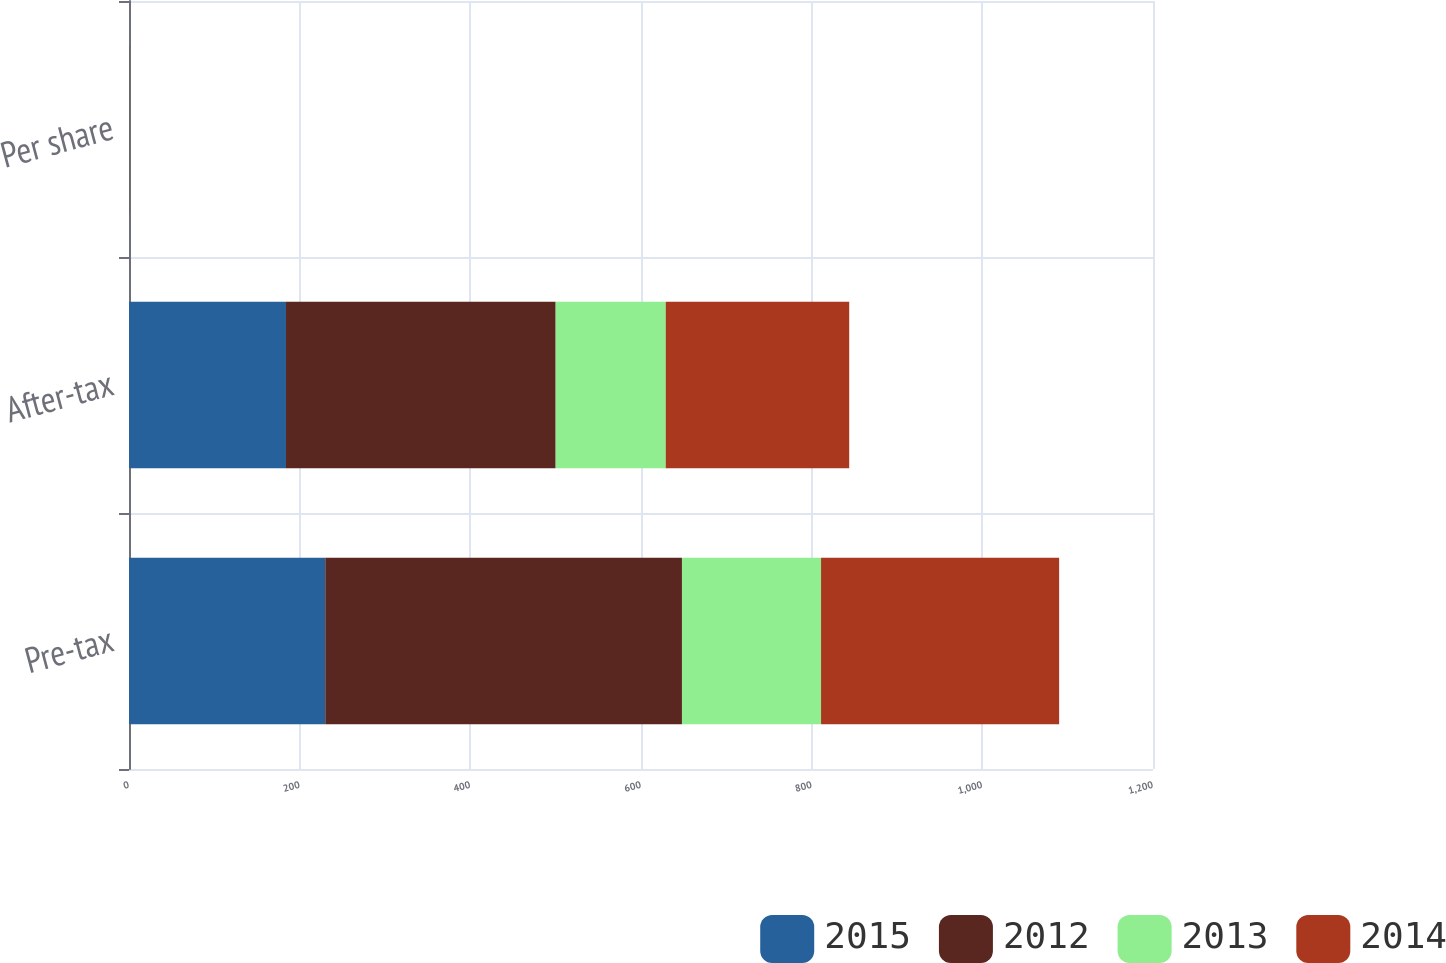Convert chart. <chart><loc_0><loc_0><loc_500><loc_500><stacked_bar_chart><ecel><fcel>Pre-tax<fcel>After-tax<fcel>Per share<nl><fcel>2015<fcel>230<fcel>184<fcel>0.12<nl><fcel>2012<fcel>418<fcel>316<fcel>0.21<nl><fcel>2013<fcel>163<fcel>129<fcel>0.08<nl><fcel>2014<fcel>279<fcel>215<fcel>0.14<nl></chart> 